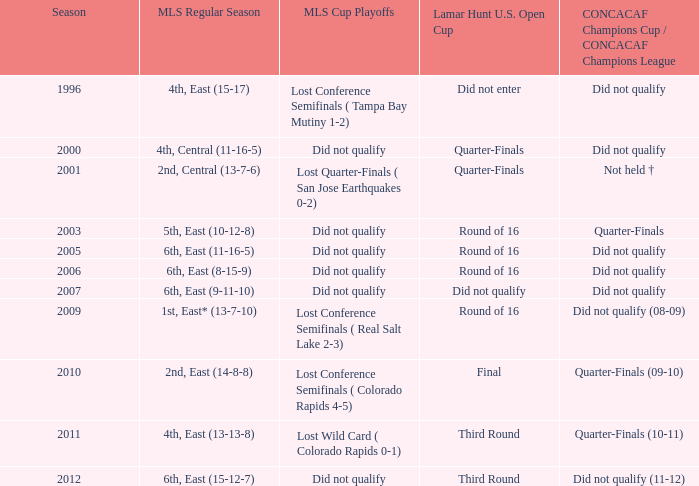Can you parse all the data within this table? {'header': ['Season', 'MLS Regular Season', 'MLS Cup Playoffs', 'Lamar Hunt U.S. Open Cup', 'CONCACAF Champions Cup / CONCACAF Champions League'], 'rows': [['1996', '4th, East (15-17)', 'Lost Conference Semifinals ( Tampa Bay Mutiny 1-2)', 'Did not enter', 'Did not qualify'], ['2000', '4th, Central (11-16-5)', 'Did not qualify', 'Quarter-Finals', 'Did not qualify'], ['2001', '2nd, Central (13-7-6)', 'Lost Quarter-Finals ( San Jose Earthquakes 0-2)', 'Quarter-Finals', 'Not held †'], ['2003', '5th, East (10-12-8)', 'Did not qualify', 'Round of 16', 'Quarter-Finals'], ['2005', '6th, East (11-16-5)', 'Did not qualify', 'Round of 16', 'Did not qualify'], ['2006', '6th, East (8-15-9)', 'Did not qualify', 'Round of 16', 'Did not qualify'], ['2007', '6th, East (9-11-10)', 'Did not qualify', 'Did not qualify', 'Did not qualify'], ['2009', '1st, East* (13-7-10)', 'Lost Conference Semifinals ( Real Salt Lake 2-3)', 'Round of 16', 'Did not qualify (08-09)'], ['2010', '2nd, East (14-8-8)', 'Lost Conference Semifinals ( Colorado Rapids 4-5)', 'Final', 'Quarter-Finals (09-10)'], ['2011', '4th, East (13-13-8)', 'Lost Wild Card ( Colorado Rapids 0-1)', 'Third Round', 'Quarter-Finals (10-11)'], ['2012', '6th, East (15-12-7)', 'Did not qualify', 'Third Round', 'Did not qualify (11-12)']]} In the 2009-2010 season, when the concacaf champions cup/champions league reached the quarter-finals, what stage were the mls cup playoffs at? Lost Conference Semifinals ( Colorado Rapids 4-5). 